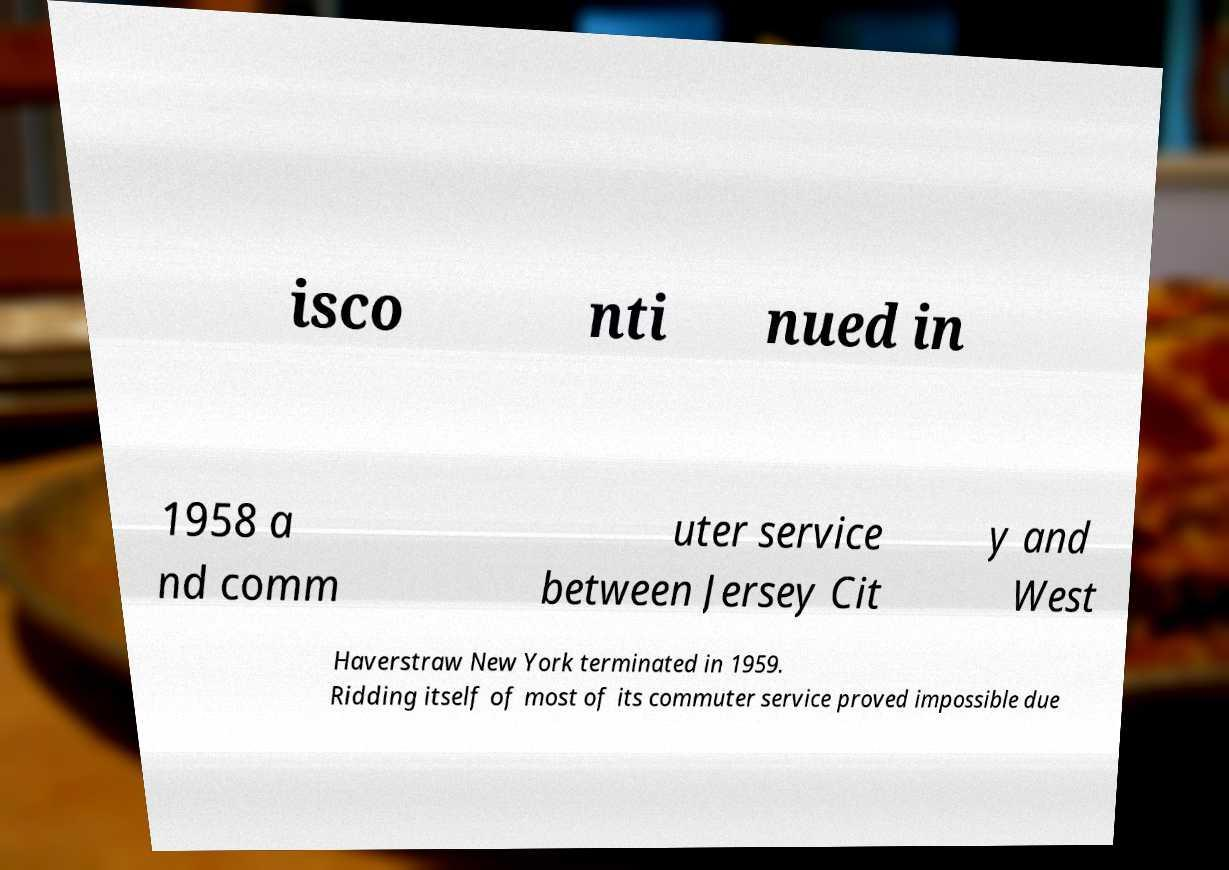Please read and relay the text visible in this image. What does it say? isco nti nued in 1958 a nd comm uter service between Jersey Cit y and West Haverstraw New York terminated in 1959. Ridding itself of most of its commuter service proved impossible due 